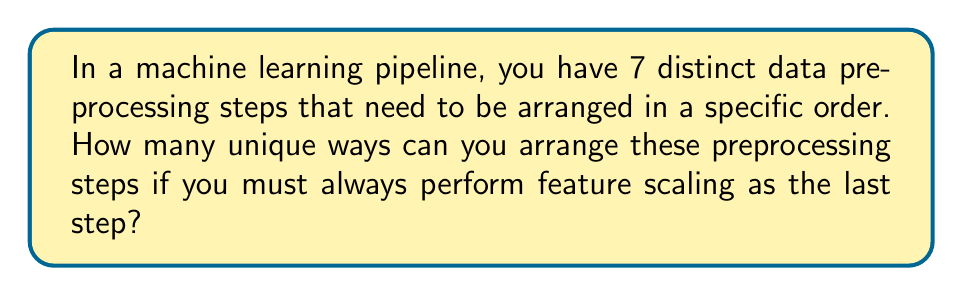Show me your answer to this math problem. Let's approach this step-by-step:

1) We have 7 distinct preprocessing steps in total.

2) One of these steps (feature scaling) must always be performed last.

3) This means we need to arrange the remaining 6 steps, and then add feature scaling at the end.

4) Arranging 6 distinct items is a straightforward permutation problem.

5) The number of permutations of n distinct objects is given by:

   $$P(n) = n!$$

6) In this case, n = 6, so we have:

   $$P(6) = 6!$$

7) Let's calculate this:

   $$6! = 6 \times 5 \times 4 \times 3 \times 2 \times 1 = 720$$

8) After arranging these 6 steps, we always add feature scaling as the last step.

Therefore, the total number of unique arrangements is 720.

This problem combines concepts from both permutations and machine learning pipelines, which aligns well with the data scientist persona specializing in Python and interested in interdisciplinary projects.
Answer: 720 